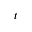Convert formula to latex. <formula><loc_0><loc_0><loc_500><loc_500>t</formula> 